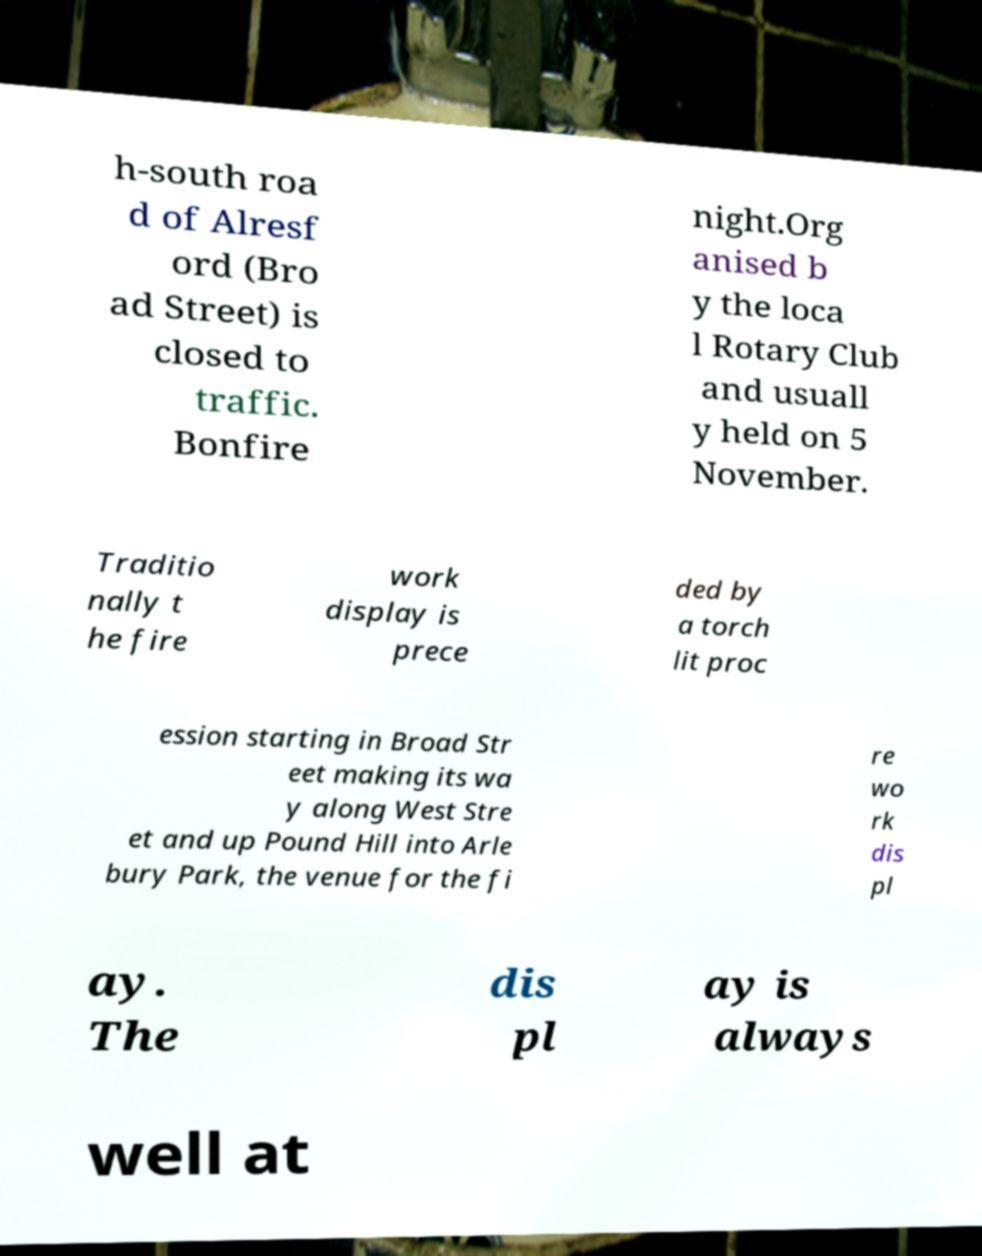Could you assist in decoding the text presented in this image and type it out clearly? h-south roa d of Alresf ord (Bro ad Street) is closed to traffic. Bonfire night.Org anised b y the loca l Rotary Club and usuall y held on 5 November. Traditio nally t he fire work display is prece ded by a torch lit proc ession starting in Broad Str eet making its wa y along West Stre et and up Pound Hill into Arle bury Park, the venue for the fi re wo rk dis pl ay. The dis pl ay is always well at 